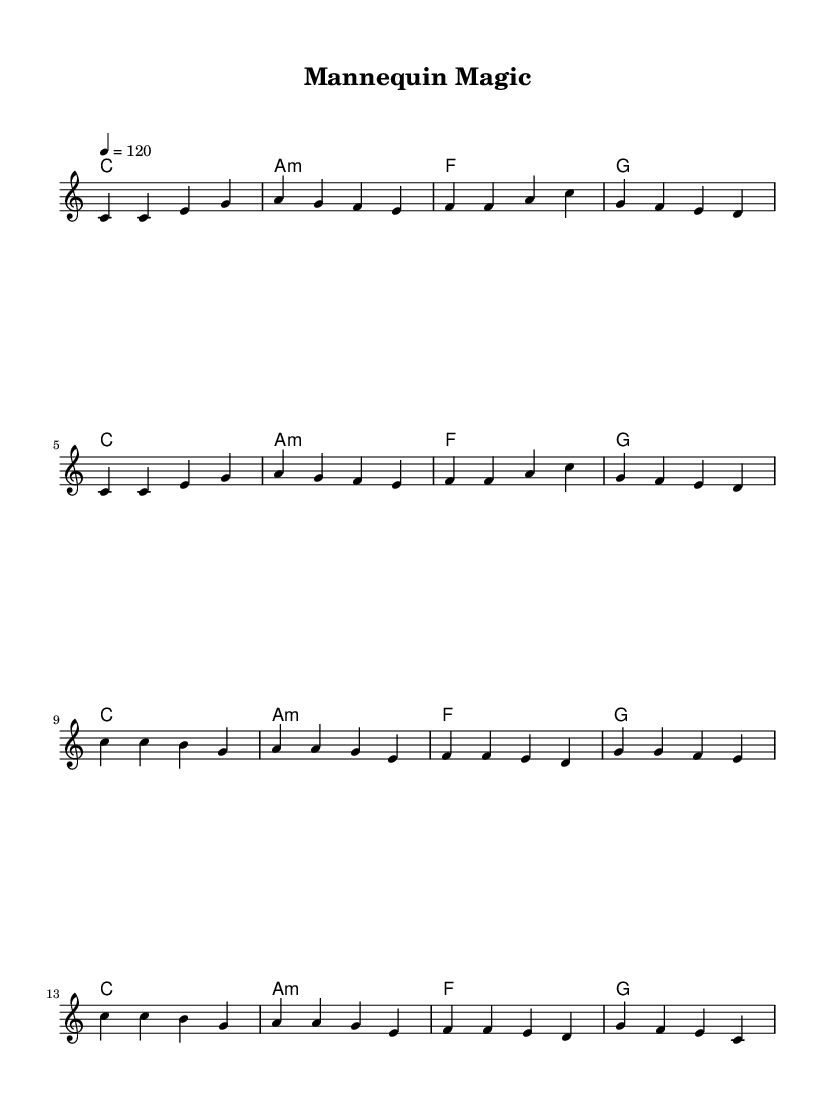What is the key signature of this music? The key signature is indicated after the word "global" in the code. It shows that the music is composed in the key of C major, which contains no sharps or flats.
Answer: C major What is the time signature of the piece? The time signature appears after the key signature and is shown as "4/4". This means there are four beats in each measure and the quarter note receives one beat.
Answer: 4/4 What is the tempo of the piece? The tempo marking is located in the "global" section and is indicated as "4 = 120", which means the quarter note is played at a speed of 120 beats per minute.
Answer: 120 How many measures are in the verse? To find the number of measures, we can count the segments of music notated under the "melody" section labeled as "Verse". Each group of notes between the vertical lines represents one measure, and there are a total of 8 measures in the verse.
Answer: 8 What is the main theme of the chorus lyrics? The chorus focuses on the creation and presentation of mannequins in a museum setting, highlighting the beauty of the exhibit and the magical process of showcasing history. This is evident from the lyrics that describe mannequin magic and exhibition aspects.
Answer: Showcasing history How many chords are used in the verse? In the code underneath the "harmonies" section, we see that 4 distinct chords are repeated in the verse. Analyzing these reveals that they are C, A minor, F, and G, which collectively constitute the harmonic foundation for the 8 measures of the verse.
Answer: 4 What is the overall mood suggested by the lyrics and melody? The lyrics and upbeat tempo suggest a cheerful and enchanting mood regarding the art of exhibition. The use of positive imagery about mannequins and costumes enhances this feeling, drawn from the evocative language in the lyrics.
Answer: Cheerful 